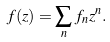Convert formula to latex. <formula><loc_0><loc_0><loc_500><loc_500>f ( z ) = \sum _ { n } f _ { n } z ^ { n } .</formula> 